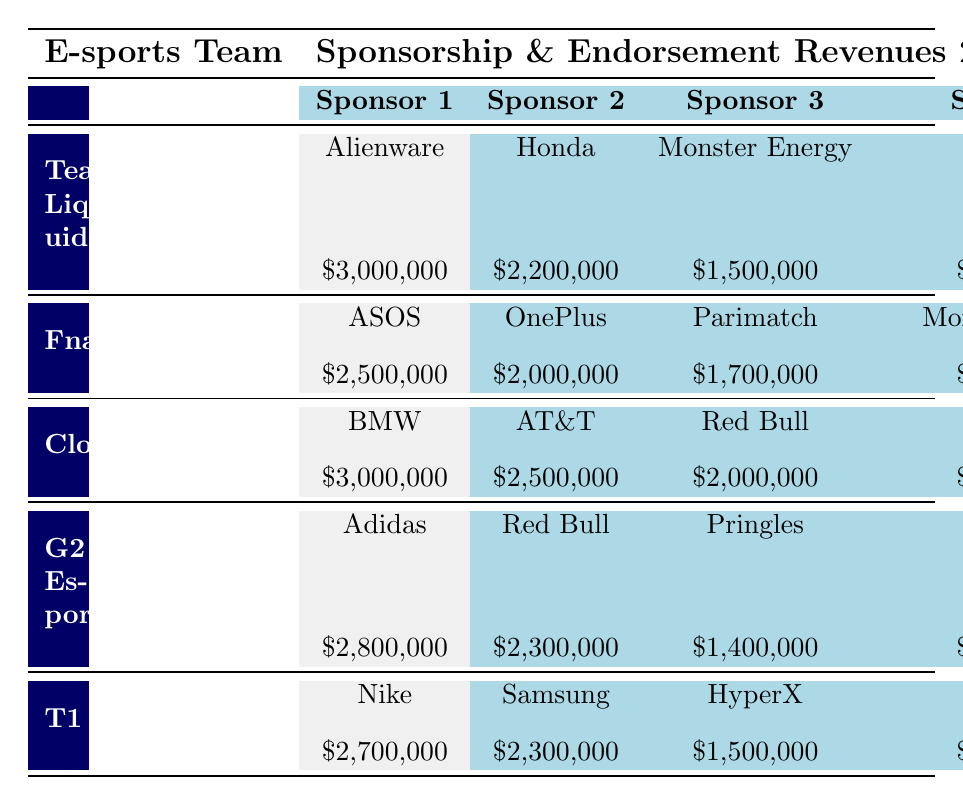What is the total sponsorship revenue for Team Liquid? To find the total revenue, we can add the amounts from each sponsor for Team Liquid: 3,000,000 + 2,200,000 + 1,500,000 + 1,800,000 = 8,500,000.
Answer: 8,500,000 Which team has the highest single sponsorship revenue? Checking the table, both Cloud9 and Team Liquid have the highest individual sponsorship amount of 3,000,000.
Answer: True What is the combined revenue for Fnatic's top two sponsors? The top two sponsors' revenues for Fnatic are 2,500,000 (ASOS) and 2,000,000 (OnePlus). Adding these gives us 2,500,000 + 2,000,000 = 4,500,000.
Answer: 4,500,000 Is it true that G2 Esports earned more from Red Bull than T1 did from Samsung? G2 Esports earned 2,300,000 from Red Bull while T1 earned 2,300,000 from Samsung. Since they are equal, the answer is false.
Answer: False What is the average sponsorship amount from all sponsors for T1? To calculate the average, we first sum all sponsors' amounts for T1: 2,700,000 + 2,300,000 + 1,500,000 + 1,400,000 = 8,900,000. There are 4 sponsors, so the average is 8,900,000 / 4 = 2,225,000.
Answer: 2,225,000 Which team received sponsorship from Monster Energy? Both Team Liquid and Fnatic received sponsorship from Monster Energy.
Answer: Team Liquid and Fnatic What is the difference in total revenue between Cloud9 and G2 Esports? Cloud9's total revenue is 11,700,000 (3,000,000 + 2,500,000 + 2,000,000 + 2,200,000) and G2 Esports' total revenue is 8,700,000 (2,800,000 + 2,300,000 + 1,400,000 + 1,600,000). The difference is 11,700,000 - 8,700,000 = 3,000,000.
Answer: 3,000,000 Did T1 receive more revenue from Nike than from Samsung? T1 received 2,700,000 from Nike and 2,300,000 from Samsung. Since 2,700,000 is greater than 2,300,000, the statement is true.
Answer: True What is the lowest individual sponsorship revenue for any team? The lowest individual sponsorship amount is 1,400,000 from both G2 Esports (Pringles) and T1 (Secretlab).
Answer: 1,400,000 